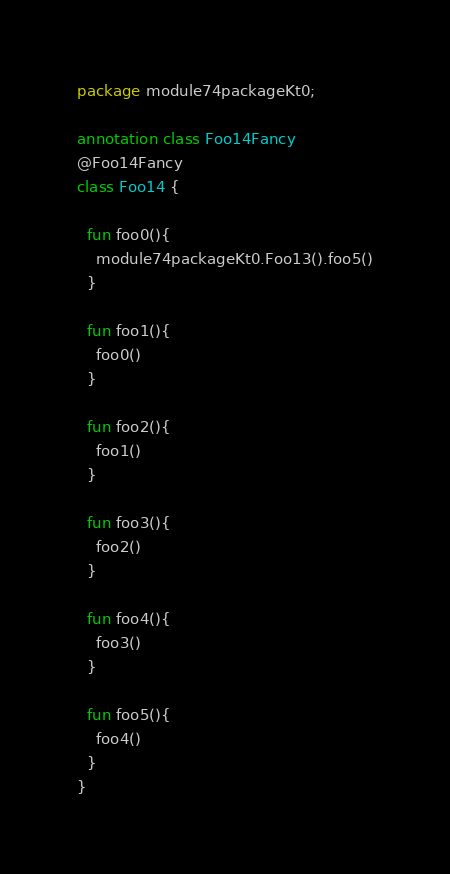Convert code to text. <code><loc_0><loc_0><loc_500><loc_500><_Kotlin_>package module74packageKt0;

annotation class Foo14Fancy
@Foo14Fancy
class Foo14 {

  fun foo0(){
    module74packageKt0.Foo13().foo5()
  }

  fun foo1(){
    foo0()
  }

  fun foo2(){
    foo1()
  }

  fun foo3(){
    foo2()
  }

  fun foo4(){
    foo3()
  }

  fun foo5(){
    foo4()
  }
}</code> 